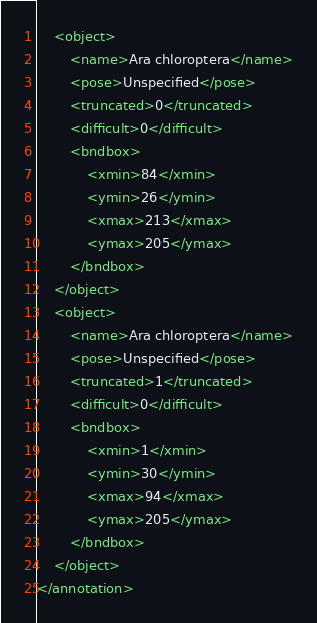Convert code to text. <code><loc_0><loc_0><loc_500><loc_500><_XML_>	<object>
		<name>Ara chloroptera</name>
		<pose>Unspecified</pose>
		<truncated>0</truncated>
		<difficult>0</difficult>
		<bndbox>
			<xmin>84</xmin>
			<ymin>26</ymin>
			<xmax>213</xmax>
			<ymax>205</ymax>
		</bndbox>
	</object>
	<object>
		<name>Ara chloroptera</name>
		<pose>Unspecified</pose>
		<truncated>1</truncated>
		<difficult>0</difficult>
		<bndbox>
			<xmin>1</xmin>
			<ymin>30</ymin>
			<xmax>94</xmax>
			<ymax>205</ymax>
		</bndbox>
	</object>
</annotation>
</code> 